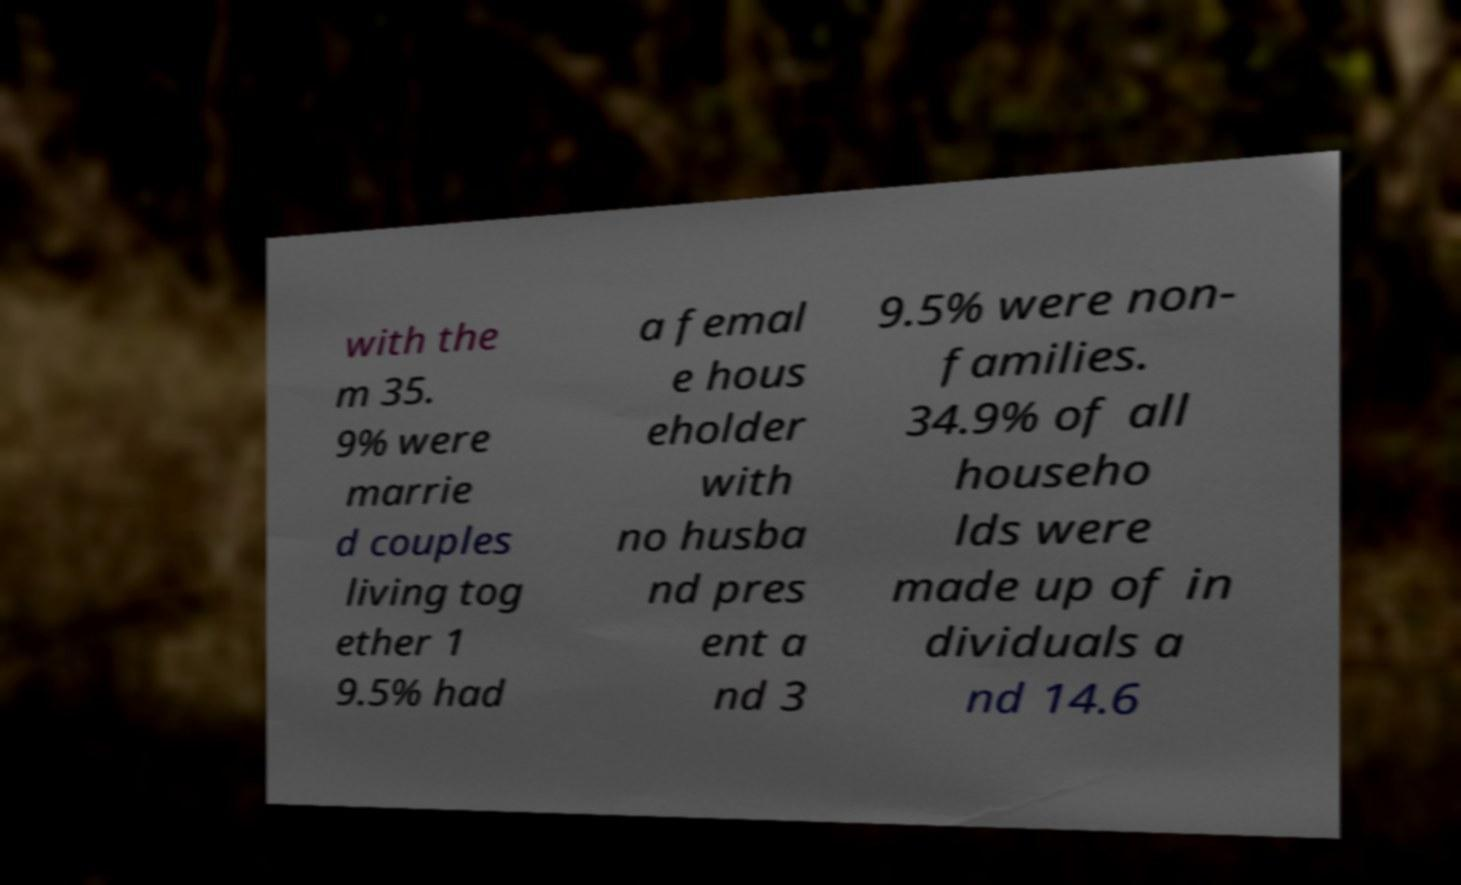Can you accurately transcribe the text from the provided image for me? with the m 35. 9% were marrie d couples living tog ether 1 9.5% had a femal e hous eholder with no husba nd pres ent a nd 3 9.5% were non- families. 34.9% of all househo lds were made up of in dividuals a nd 14.6 